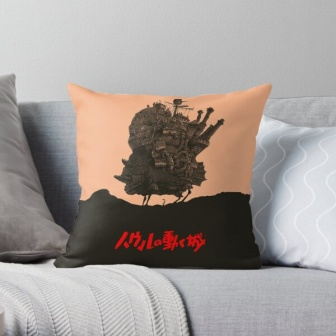What is this photo about'? The image shows a cozy and well-decorated living room scene with focus on a stylish throw pillow placed against the arm of a gray couch. The pillow itself is divided into two distinct color blocks: the top half is a soft peach color, and the bottom half is black. The peach section is adorned with a detailed black illustration of a whimsical, castle-like structure with numerous towers and flags, creating a magical atmosphere. On the black section, the word 'Miyazaki' is prominently displayed in a vibrant, red font, likely referencing the famous animator Hayao Miyazaki. A gray blanket with a white geometric pattern is also present, draped over the arm of the couch, adding to the overall cozy and inviting ambiance of the scene. 